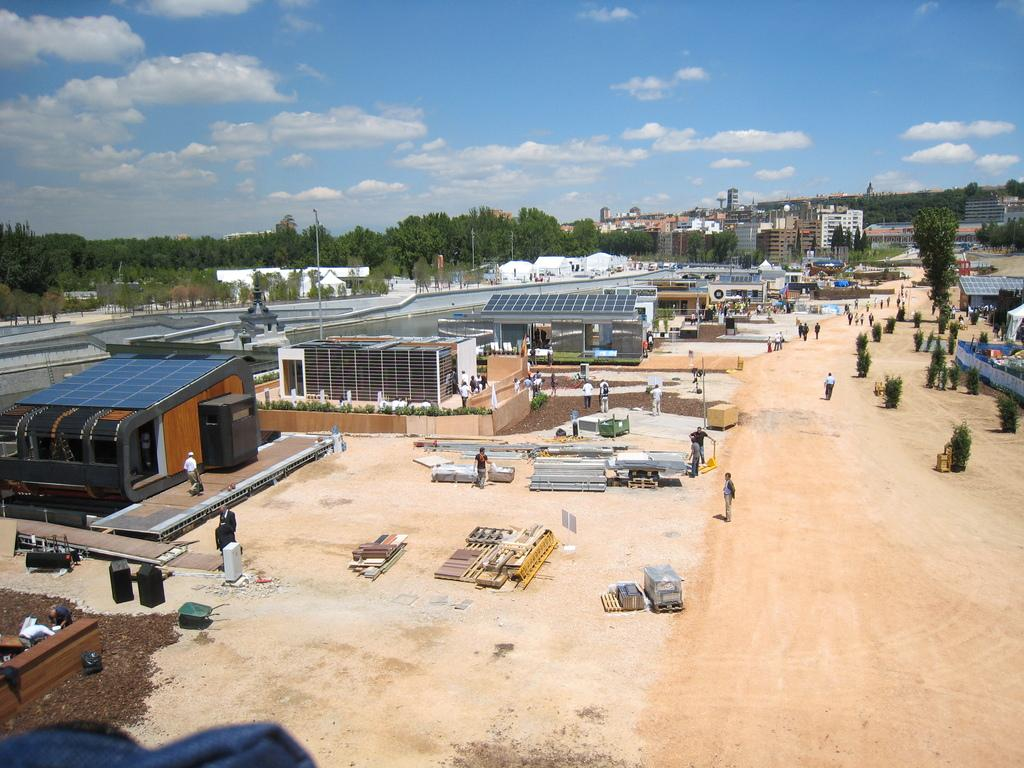What type of structures can be seen in the image? There are factories and buildings in the image. What can be found on the ground in the image? There are iron items on the ground. What is the presence of people in the image suggestive of? There are people standing on the ground in the image, which suggests that there may be some activity or gathering taking place. What can be seen in the background of the image? There are trees visible in the background. What type of meal is being prepared by the carpenter in the image? There is no carpenter or meal preparation visible in the image. What activity is the group of people engaged in with the trees in the background? There is no specific activity mentioned or depicted in the image involving the trees in the background. 